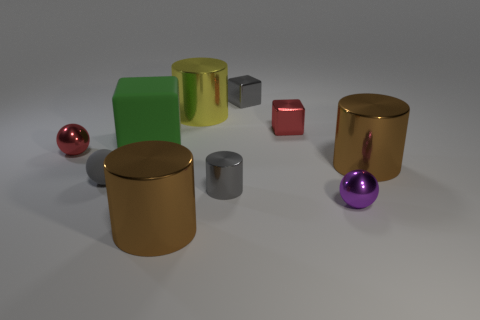Subtract all red metal cubes. How many cubes are left? 2 Subtract all balls. How many objects are left? 7 Subtract all brown cylinders. How many cylinders are left? 2 Subtract all green balls. How many purple cubes are left? 0 Subtract all large green blocks. Subtract all large matte blocks. How many objects are left? 8 Add 4 purple shiny balls. How many purple shiny balls are left? 5 Add 5 big blue rubber cylinders. How many big blue rubber cylinders exist? 5 Subtract 0 purple cubes. How many objects are left? 10 Subtract 1 balls. How many balls are left? 2 Subtract all brown blocks. Subtract all blue balls. How many blocks are left? 3 